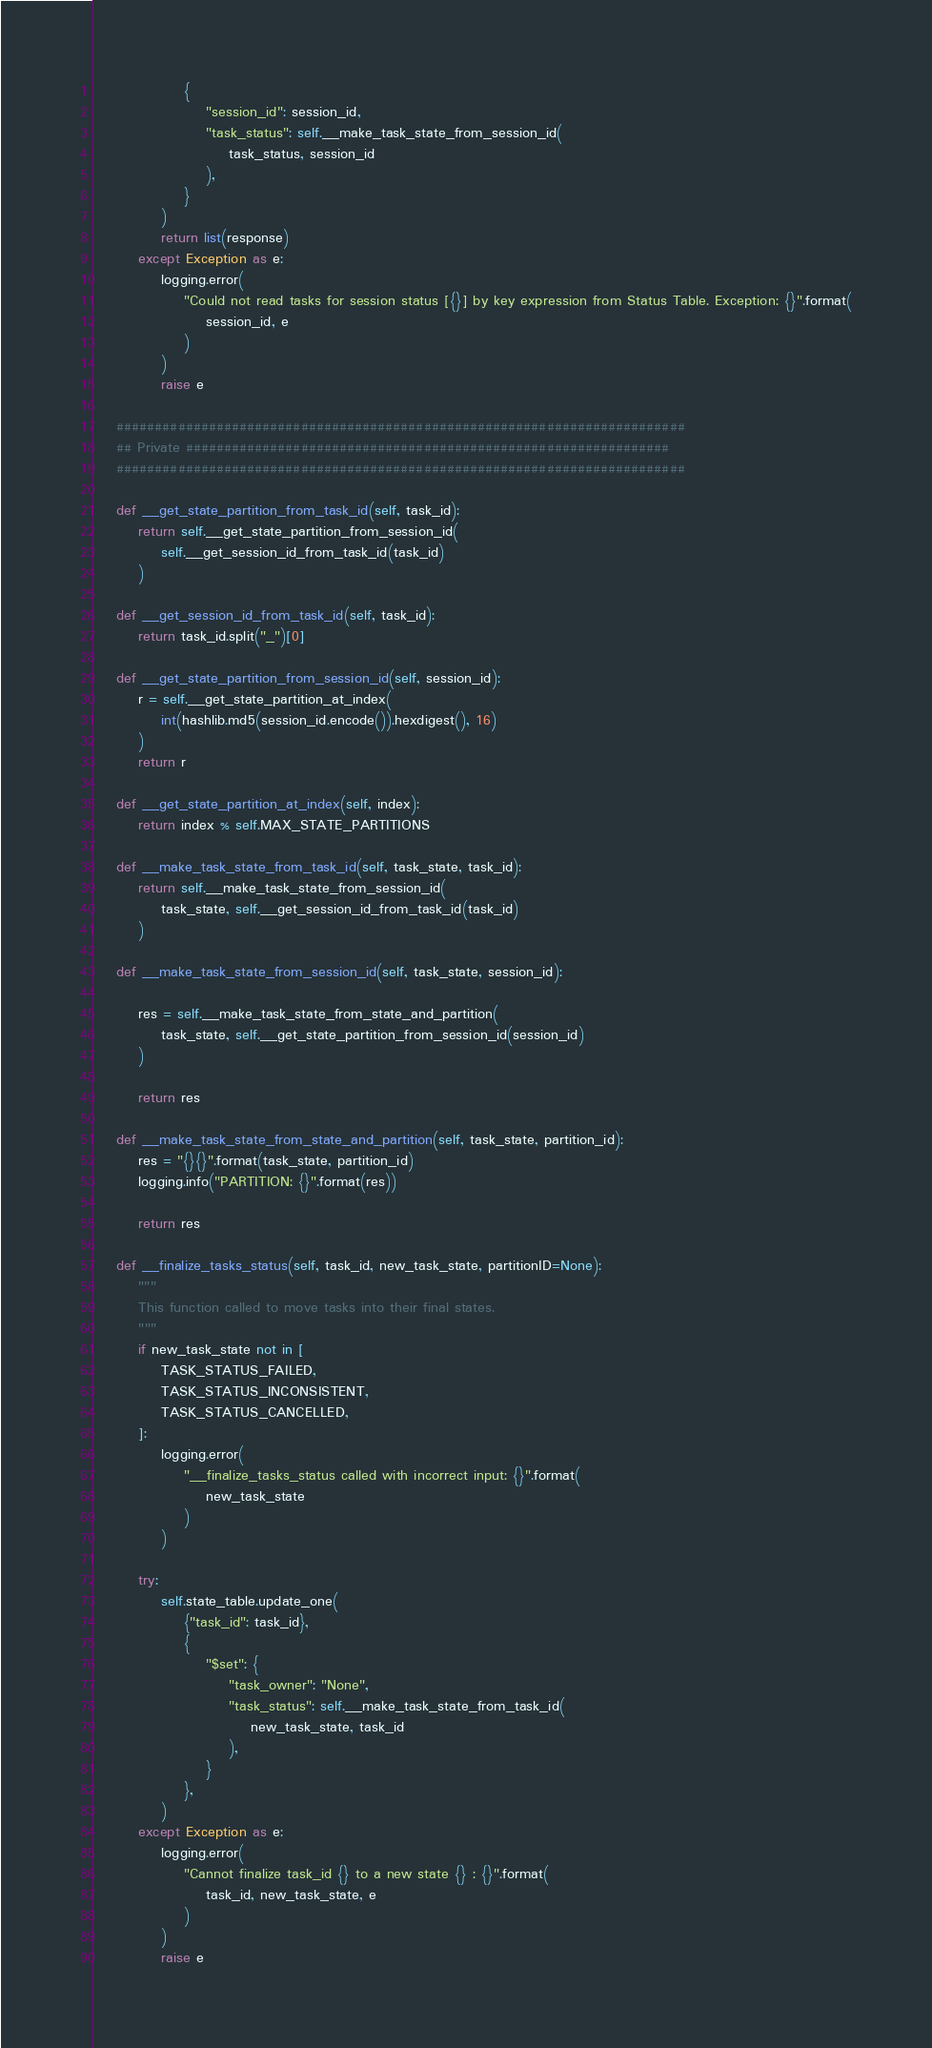Convert code to text. <code><loc_0><loc_0><loc_500><loc_500><_Python_>                {
                    "session_id": session_id,
                    "task_status": self.__make_task_state_from_session_id(
                        task_status, session_id
                    ),
                }
            )
            return list(response)
        except Exception as e:
            logging.error(
                "Could not read tasks for session status [{}] by key expression from Status Table. Exception: {}".format(
                    session_id, e
                )
            )
            raise e

    ##########################################################################
    ## Private ###############################################################
    ##########################################################################

    def __get_state_partition_from_task_id(self, task_id):
        return self.__get_state_partition_from_session_id(
            self.__get_session_id_from_task_id(task_id)
        )

    def __get_session_id_from_task_id(self, task_id):
        return task_id.split("_")[0]

    def __get_state_partition_from_session_id(self, session_id):
        r = self.__get_state_partition_at_index(
            int(hashlib.md5(session_id.encode()).hexdigest(), 16)
        )
        return r

    def __get_state_partition_at_index(self, index):
        return index % self.MAX_STATE_PARTITIONS

    def __make_task_state_from_task_id(self, task_state, task_id):
        return self.__make_task_state_from_session_id(
            task_state, self.__get_session_id_from_task_id(task_id)
        )

    def __make_task_state_from_session_id(self, task_state, session_id):

        res = self.__make_task_state_from_state_and_partition(
            task_state, self.__get_state_partition_from_session_id(session_id)
        )

        return res

    def __make_task_state_from_state_and_partition(self, task_state, partition_id):
        res = "{}{}".format(task_state, partition_id)
        logging.info("PARTITION: {}".format(res))

        return res

    def __finalize_tasks_status(self, task_id, new_task_state, partitionID=None):
        """
        This function called to move tasks into their final states.
        """
        if new_task_state not in [
            TASK_STATUS_FAILED,
            TASK_STATUS_INCONSISTENT,
            TASK_STATUS_CANCELLED,
        ]:
            logging.error(
                "__finalize_tasks_status called with incorrect input: {}".format(
                    new_task_state
                )
            )

        try:
            self.state_table.update_one(
                {"task_id": task_id},
                {
                    "$set": {
                        "task_owner": "None",
                        "task_status": self.__make_task_state_from_task_id(
                            new_task_state, task_id
                        ),
                    }
                },
            )
        except Exception as e:
            logging.error(
                "Cannot finalize task_id {} to a new state {} : {}".format(
                    task_id, new_task_state, e
                )
            )
            raise e
</code> 